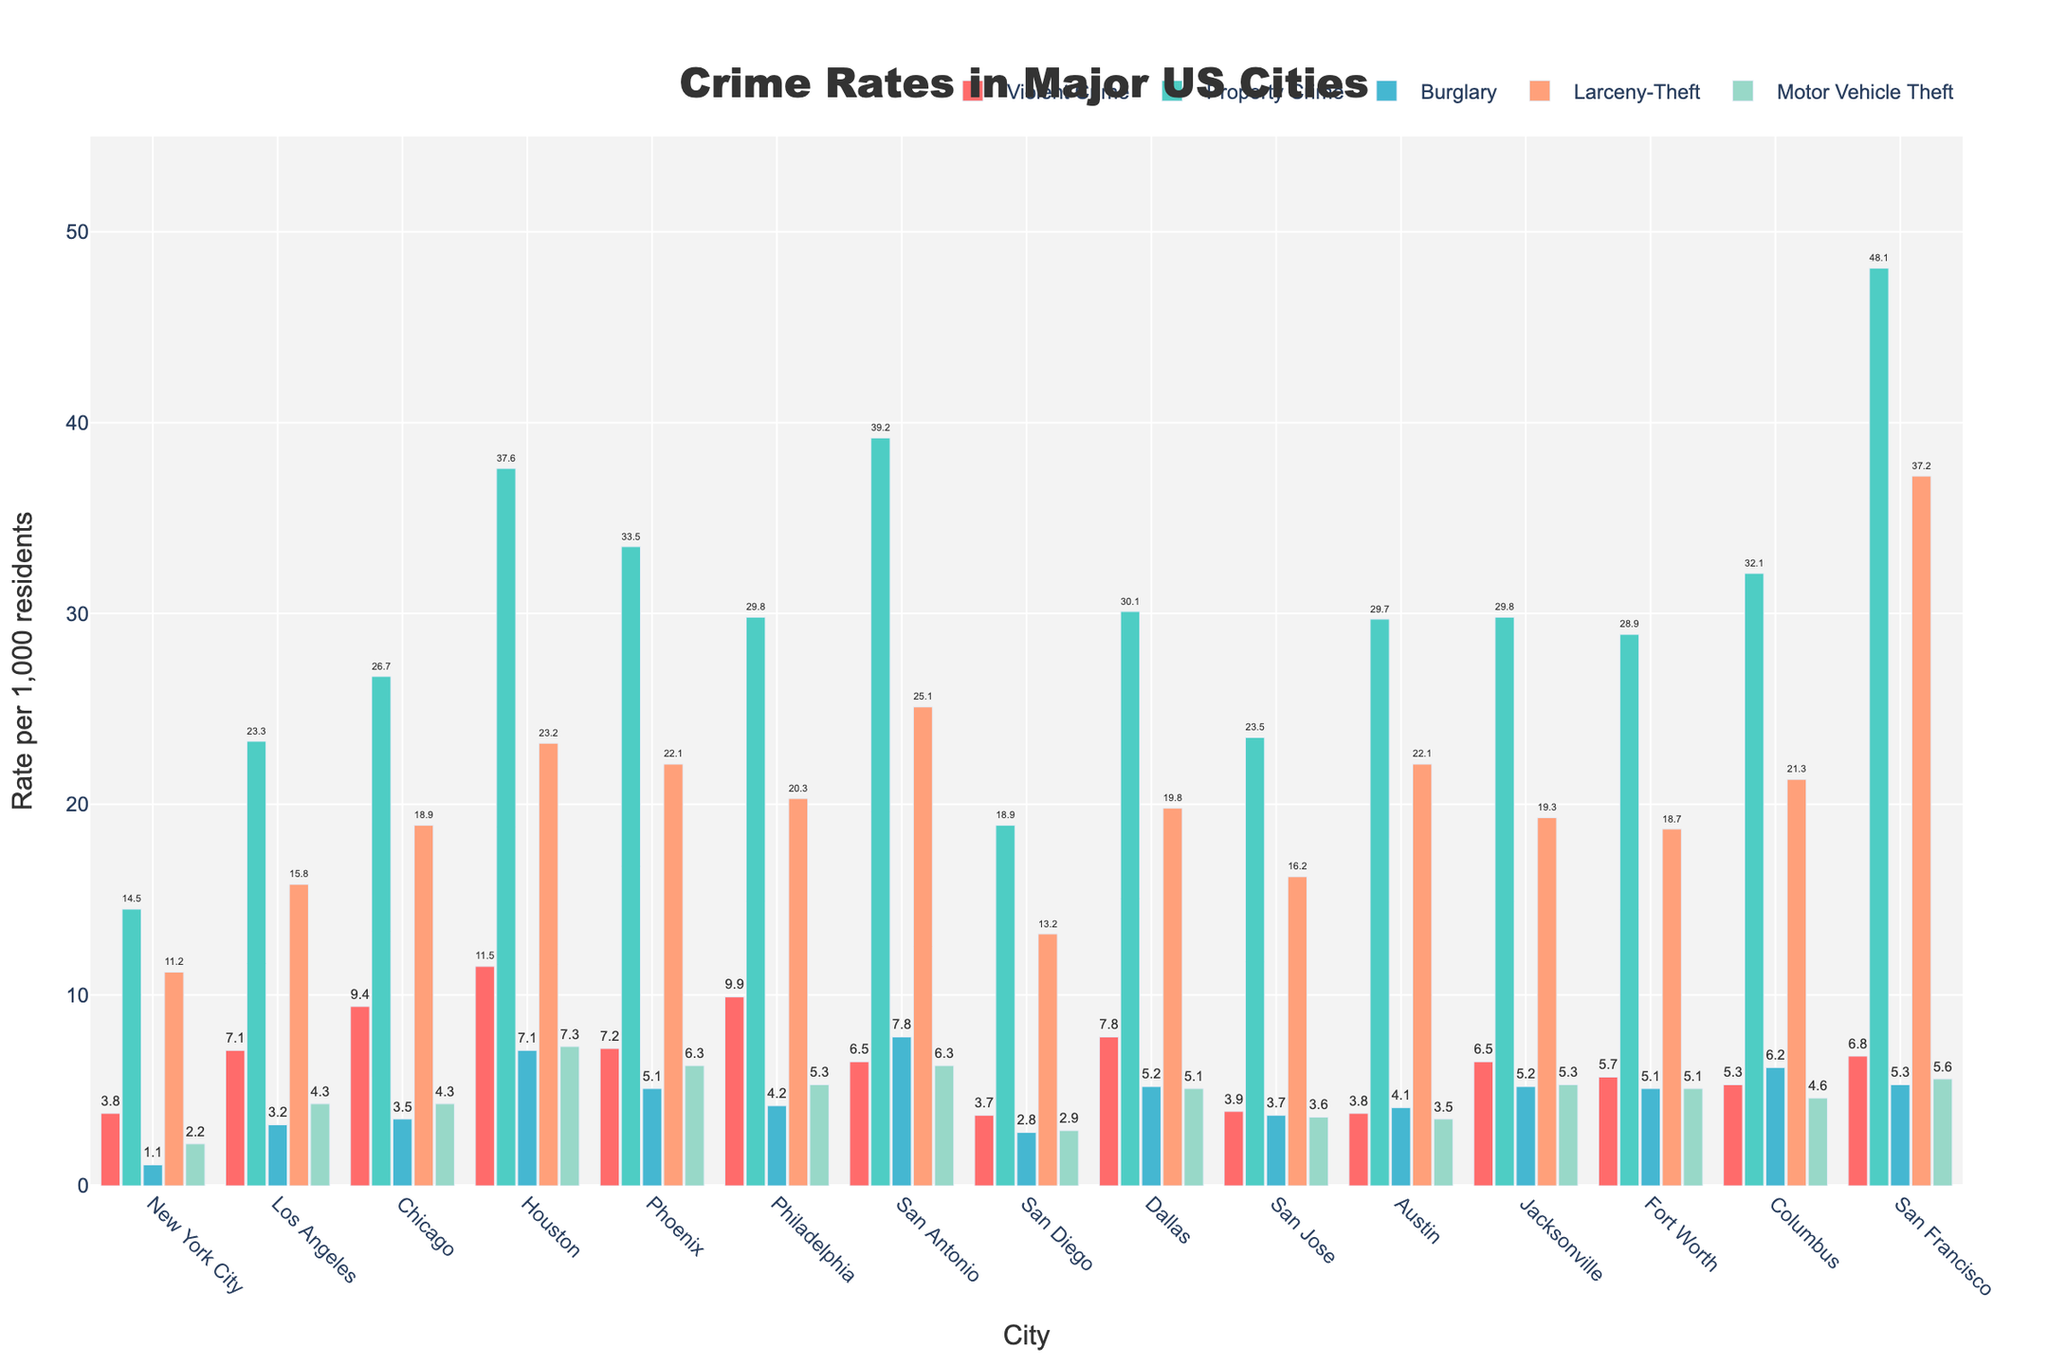Which city has the highest rate of violent crime? By observing the heights of the bars that represent violent crime rates, the highest bar corresponds to Houston.
Answer: Houston What is the difference in the rate of motor vehicle theft between Houston and Phoenix? The rate of motor vehicle theft for Houston is 7.3 and for Phoenix is 6.3. The difference is calculated as 7.3 - 6.3 = 1.0.
Answer: 1.0 Which city has the lowest property crime rate, and what is the value? By observing the bars representing property crime rates, the shortest bar corresponds to New York City. The value is 14.5.
Answer: New York City, 14.5 How does the burglary rate in San Antonio compare to that in San Diego? The burglary rate in San Antonio is 7.8, whereas in San Diego, it is 2.8. Therefore, San Antonio has a higher burglary rate than San Diego.
Answer: San Antonio has a higher rate Which color bar represents larceny-theft rates, and what is it for San Francisco? The bar color for larceny-theft is observed to be light orange, and the larceny-theft rate for San Francisco is 37.2.
Answer: Light orange, 37.2 What is the average rate of violent crime across all the cities? Sum the violent crime rates of all cities and divide by the number of cities: (3.8 + 7.1 + 9.4 + 11.5 + 7.2 + 9.9 + 6.5 + 3.7 + 7.8 + 3.9 + 3.8 + 6.5 + 5.7 + 5.3 + 6.8)/15 = 101.1/15 = 6.7 (approximately).
Answer: 6.7 What is the combined rate of property crime and motor vehicle theft in Philadelphia? The property crime rate in Philadelphia is 29.8, and the motor vehicle theft rate is 5.3. The combined rate is calculated as 29.8 + 5.3 = 35.1.
Answer: 35.1 Which city has the second-highest rate of larceny-theft? The larceny-theft rates in descending order are 37.2 (San Francisco), 25.1 (San Antonio), followed by others. Therefore, the second-highest is San Antonio.
Answer: San Antonio Is the rate of burglary in Columbus greater than the rate of motor vehicle theft in San Jose? The burglary rate in Columbus is 6.2 and the motor vehicle theft rate in San Jose is 3.6. Since 6.2 is greater than 3.6, the burglary rate in Columbus is indeed greater.
Answer: Yes Which three cities have the highest combined rates of property crime and burglary? For each city, sum the property crime and burglary rates: New York City (15.6), Los Angeles (26.5), Chicago (30.2), Houston (44.7), Phoenix (38.6), Philadelphia (34.0), San Antonio (47.0), San Diego (21.7), Dallas (35.3), San Jose (27.2), Austin (33.8), Jacksonville (35.0), Fort Worth (34.0), Columbus (38.3), San Francisco (53.4). The top three are San Francisco, San Antonio, and Houston.
Answer: San Francisco, San Antonio, Houston 